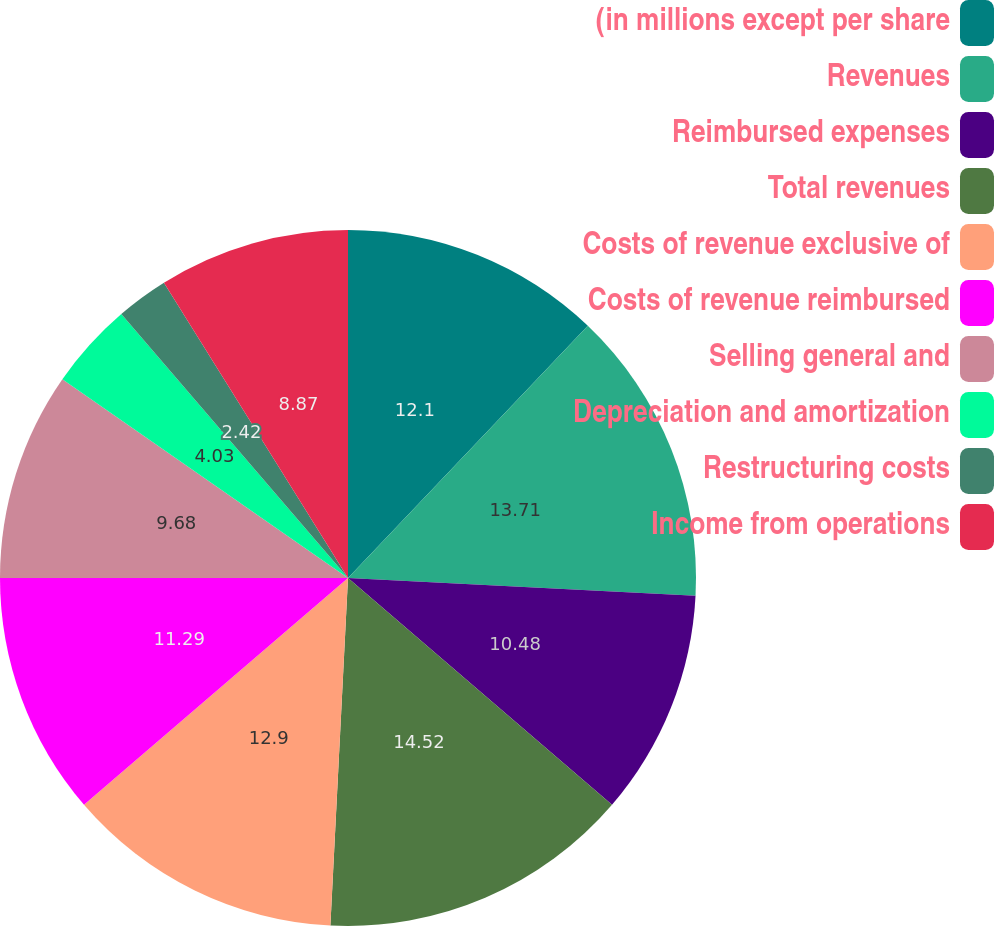Convert chart. <chart><loc_0><loc_0><loc_500><loc_500><pie_chart><fcel>(in millions except per share<fcel>Revenues<fcel>Reimbursed expenses<fcel>Total revenues<fcel>Costs of revenue exclusive of<fcel>Costs of revenue reimbursed<fcel>Selling general and<fcel>Depreciation and amortization<fcel>Restructuring costs<fcel>Income from operations<nl><fcel>12.1%<fcel>13.71%<fcel>10.48%<fcel>14.51%<fcel>12.9%<fcel>11.29%<fcel>9.68%<fcel>4.03%<fcel>2.42%<fcel>8.87%<nl></chart> 